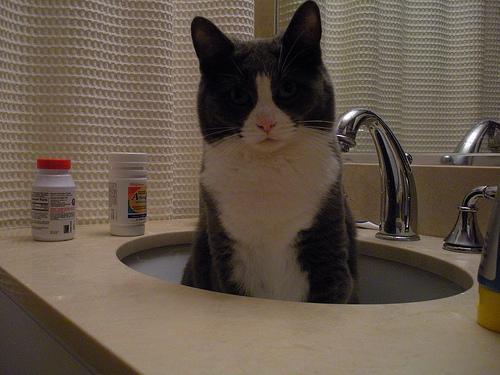How many cat are there?
Give a very brief answer. 1. 